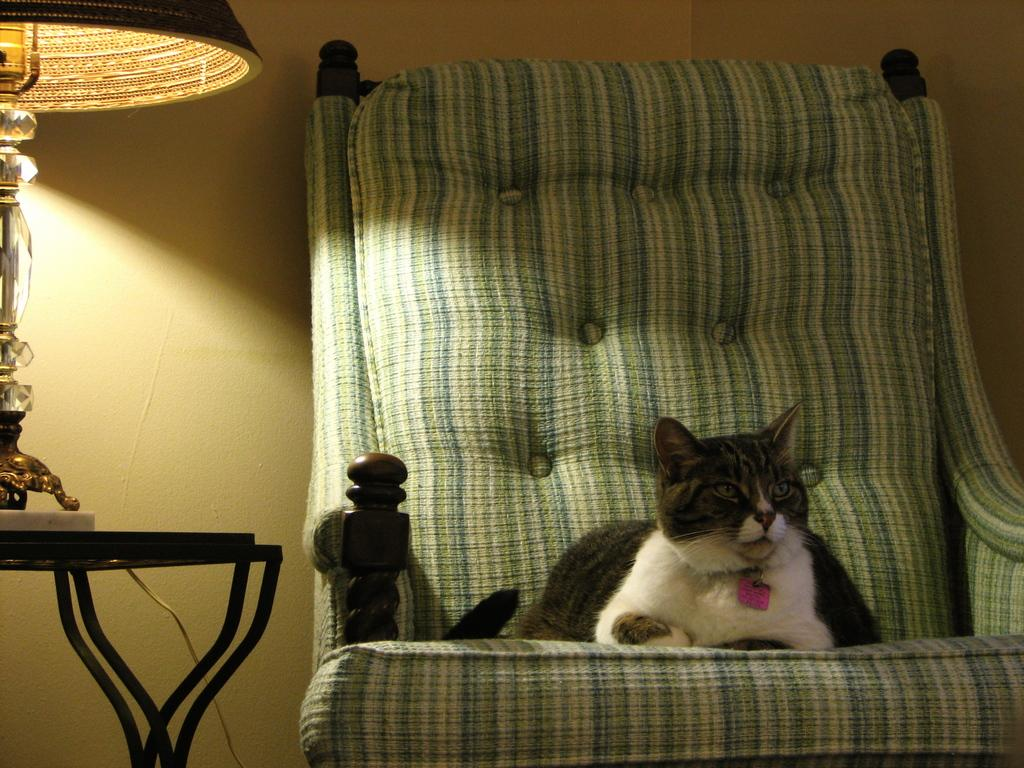What animal can be seen in the image? There is a cat in the image. Where is the cat located? The cat is sitting on a chair. What is on the left side of the image? There is a table on the left side of the image. What object is on the table? There is a lamp on the table. What color is the wall in the background of the image? The background of the image features a cream-colored wall. How many trees can be seen in the image? There are no trees visible in the image. What type of goose is sitting on the chair next to the cat? There is no goose present in the image; only a cat is sitting on the chair. 